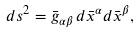Convert formula to latex. <formula><loc_0><loc_0><loc_500><loc_500>d s ^ { 2 } = \bar { g } _ { \alpha \beta } \, d \bar { x } ^ { \alpha } d \bar { x } ^ { \beta } ,</formula> 